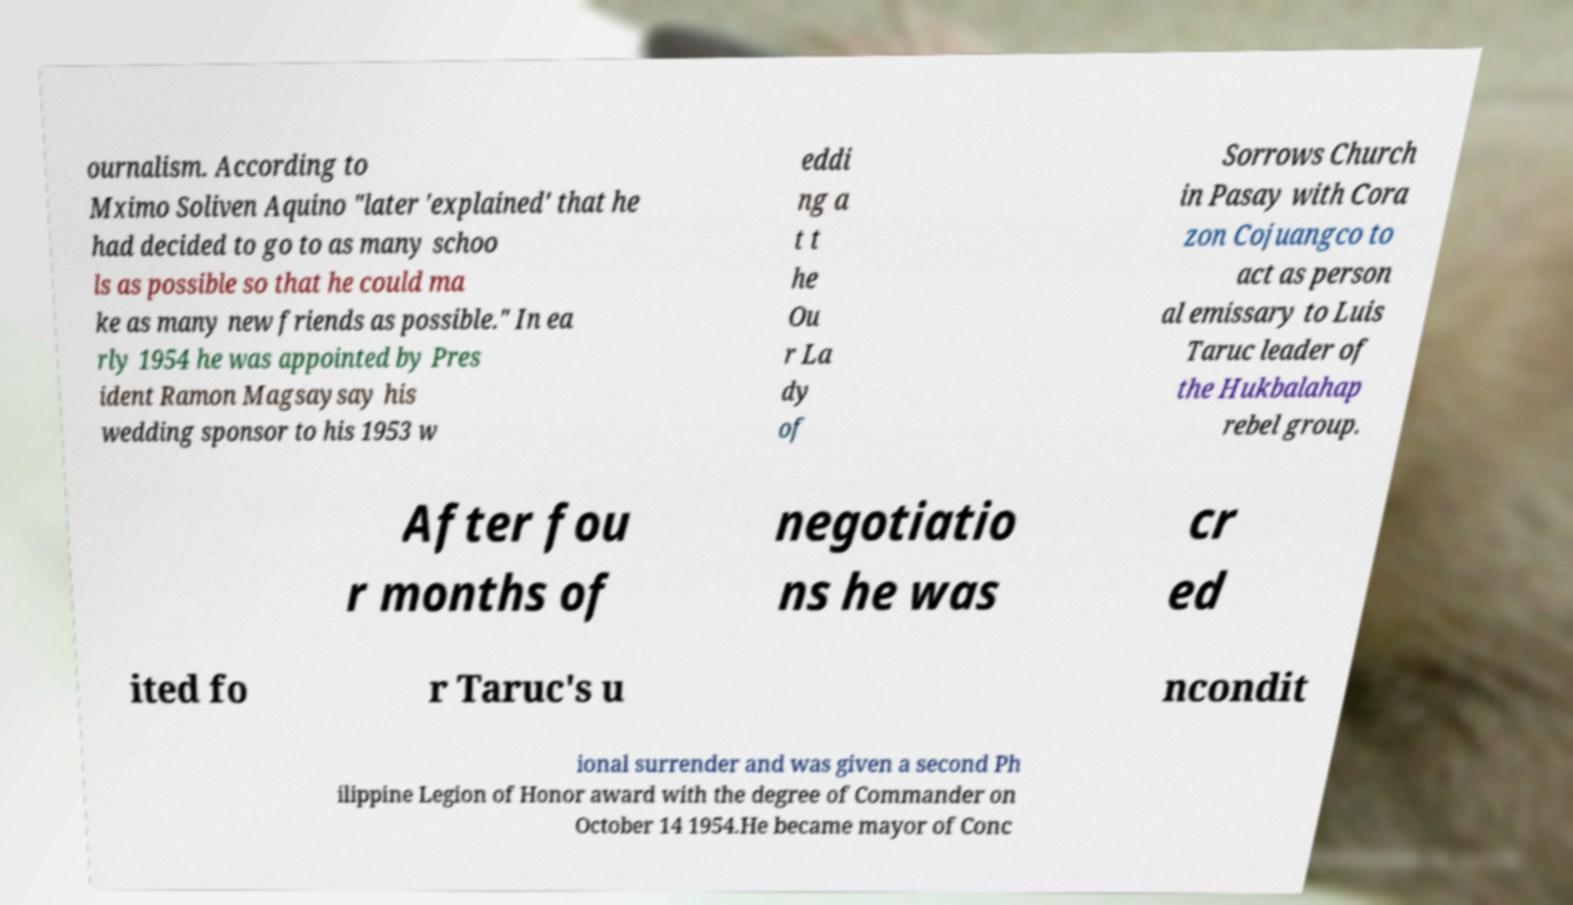Could you assist in decoding the text presented in this image and type it out clearly? ournalism. According to Mximo Soliven Aquino "later 'explained' that he had decided to go to as many schoo ls as possible so that he could ma ke as many new friends as possible." In ea rly 1954 he was appointed by Pres ident Ramon Magsaysay his wedding sponsor to his 1953 w eddi ng a t t he Ou r La dy of Sorrows Church in Pasay with Cora zon Cojuangco to act as person al emissary to Luis Taruc leader of the Hukbalahap rebel group. After fou r months of negotiatio ns he was cr ed ited fo r Taruc's u ncondit ional surrender and was given a second Ph ilippine Legion of Honor award with the degree of Commander on October 14 1954.He became mayor of Conc 